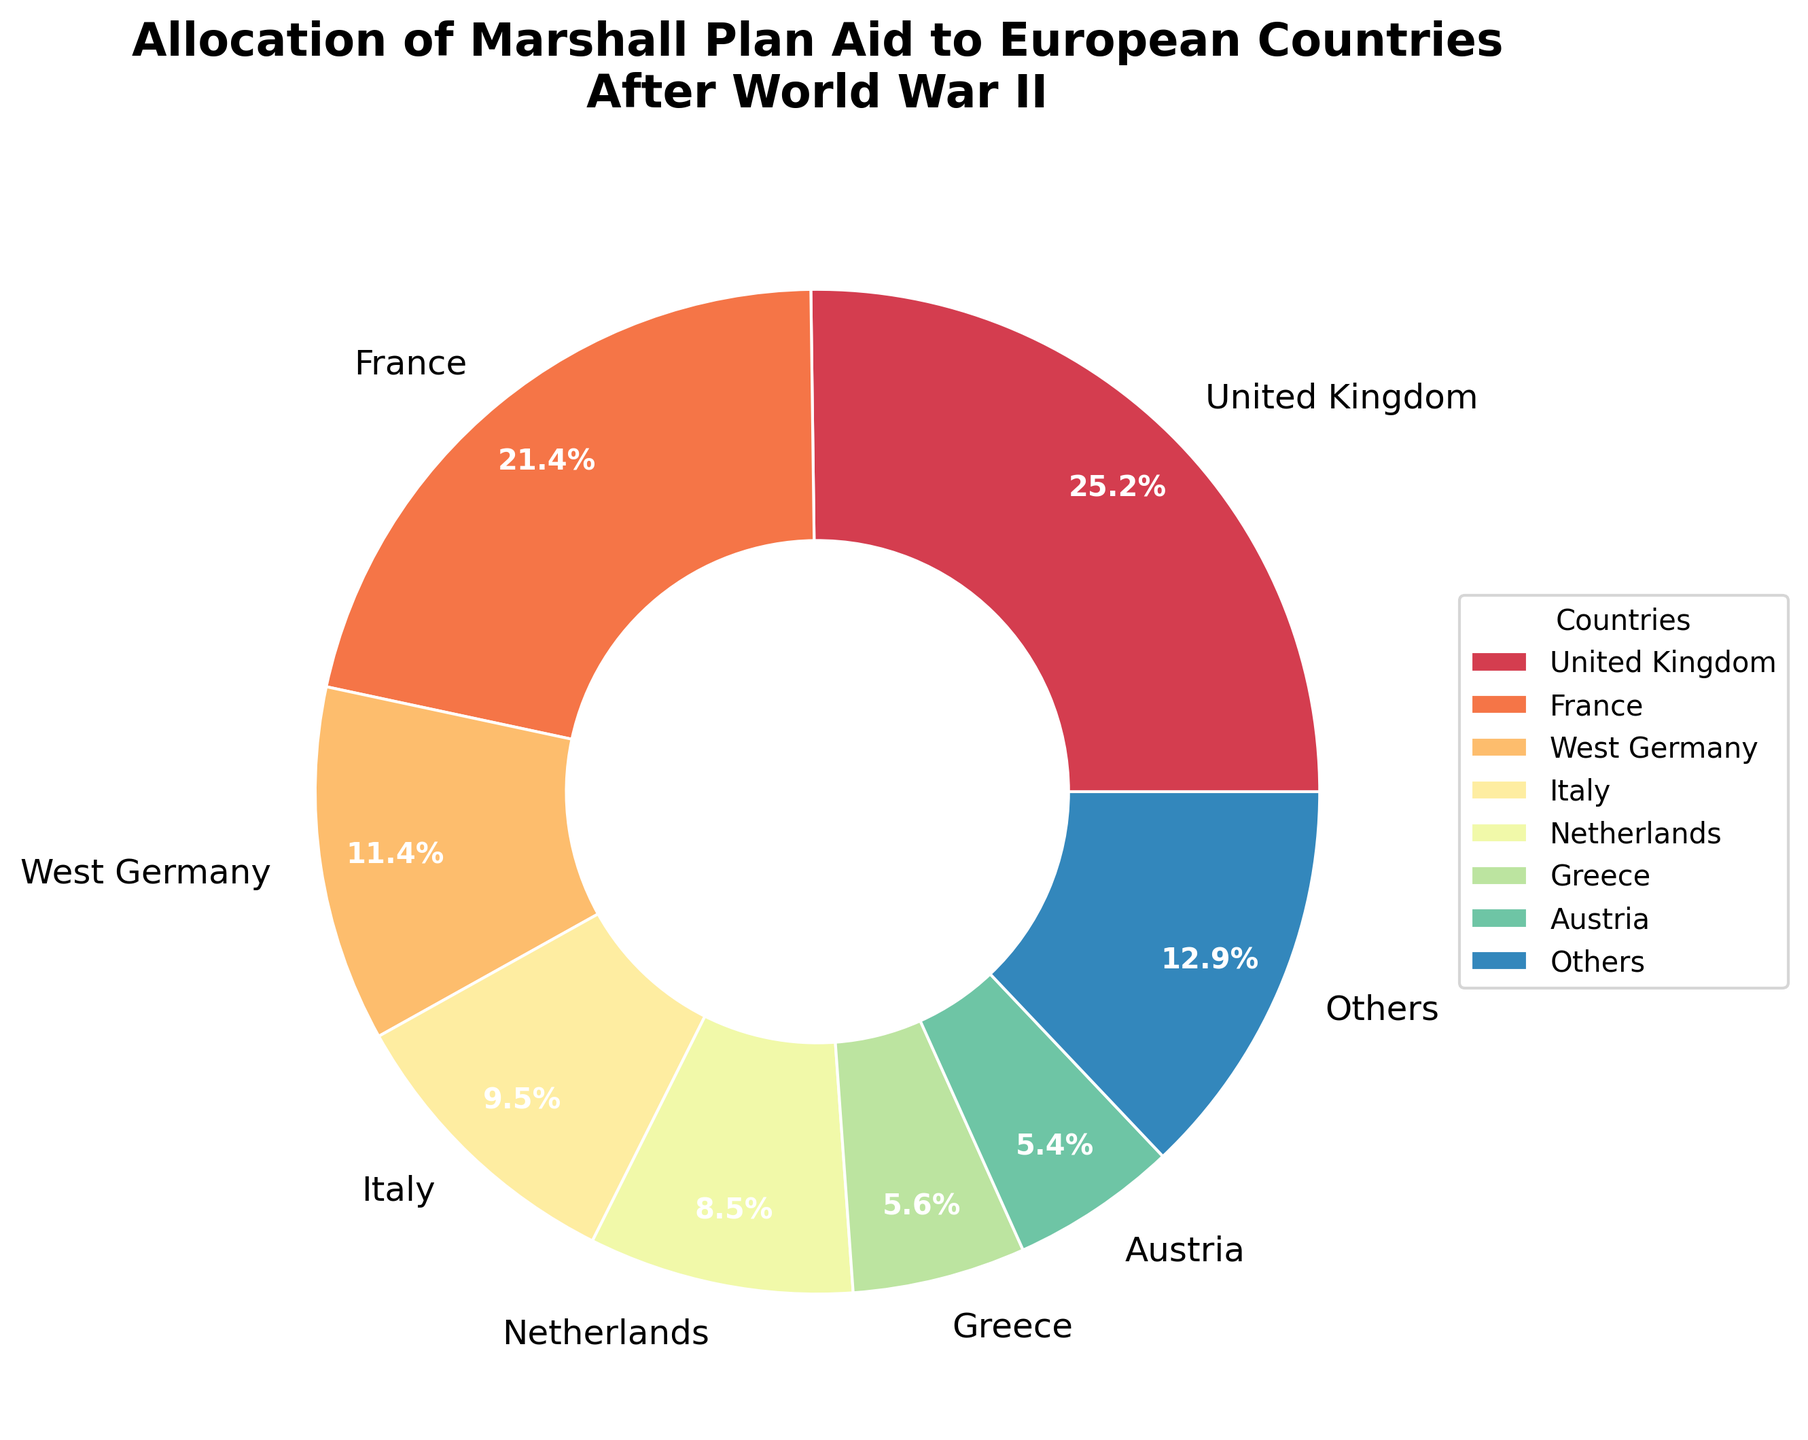Which country received the highest percentage of Marshall Plan aid? The UK has the largest wedge in the pie chart, which indicates it received the highest percentage of the aid.
Answer: United Kingdom Which country received more aid, France or Italy? By comparing the wedges in the pie chart, France's wedge is larger than Italy's, indicating it received more aid.
Answer: France What percentage of the aid did the top three countries receive in total? Add the percentages of the UK, France, and West Germany from the chart: around 26.8% + 22.8% + 12.2% = 61.8%.
Answer: 61.8% How does the aid to Greece compare to the aid to Austria? Greece's wedge is slightly larger than Austria's, meaning Greece received more aid.
Answer: Greece Which countries make up the 'Others' category, and what is their combined aid percentage? The countries that are not in the top 7 fall under 'Others.' They are Belgium, Denmark, Norway, Turkey, Ireland, Sweden, and Portugal. Summing their respective percentages from smallest wedges: approximately 4.7% + 2.3% + 2.2% + 1.9% + 1.2% + 0.8% + 0.5% = 13.6%.
Answer: Belgium, Denmark, Norway, Turkey, Ireland, Sweden, Portugal, 13.6% Which of the top seven countries has the smallest percentage of Marshall Plan aid? Austria is the last listed of the top seven, with a smaller wedge compared to the others in the top seven.
Answer: Austria How much larger is the aid percentage for the United Kingdom compared to that for West Germany? The aid percentage for the UK is about 26.8%, and for West Germany it is approximately 12.2%. The difference is 26.8% - 12.2% = 14.6%.
Answer: 14.6% If you combined the aid percentages of the Netherlands and Greece, how would it compare to the percentage received by France? The Netherlands has around 9.1% and Greece has about 5.9%. Combined, they sum to 15%. France's aid is roughly 22.8%. 15% is less than 22.8%.
Answer: Less than France What is the combined aid percentage for Italy and the Netherlands? Italy has approximately 10.1%, and the Netherlands has around 9.1%. Combined, they are 10.1% + 9.1% = 19.2%.
Answer: 19.2% 